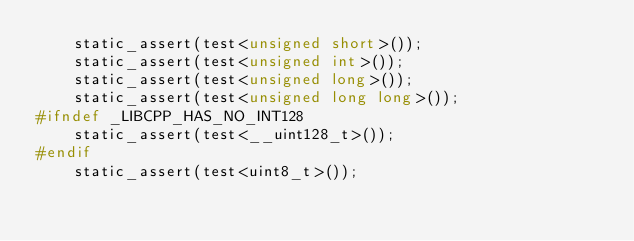<code> <loc_0><loc_0><loc_500><loc_500><_C++_>    static_assert(test<unsigned short>());
    static_assert(test<unsigned int>());
    static_assert(test<unsigned long>());
    static_assert(test<unsigned long long>());
#ifndef _LIBCPP_HAS_NO_INT128
    static_assert(test<__uint128_t>());
#endif
    static_assert(test<uint8_t>());</code> 